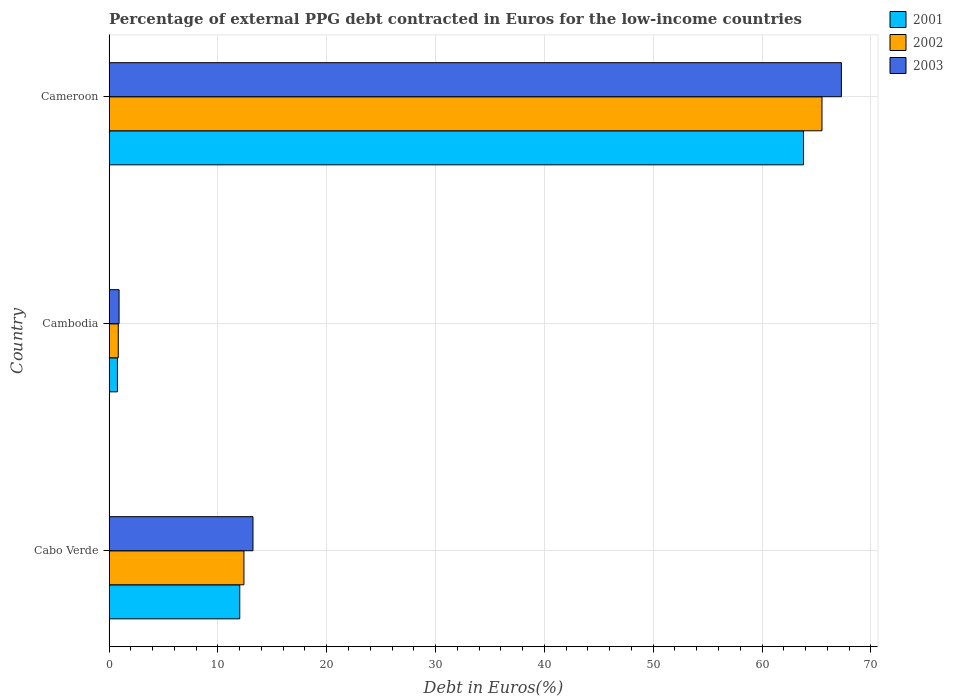How many different coloured bars are there?
Your answer should be very brief. 3. How many groups of bars are there?
Give a very brief answer. 3. Are the number of bars per tick equal to the number of legend labels?
Your response must be concise. Yes. What is the label of the 2nd group of bars from the top?
Your response must be concise. Cambodia. What is the percentage of external PPG debt contracted in Euros in 2002 in Cameroon?
Your response must be concise. 65.51. Across all countries, what is the maximum percentage of external PPG debt contracted in Euros in 2003?
Offer a terse response. 67.29. Across all countries, what is the minimum percentage of external PPG debt contracted in Euros in 2001?
Offer a terse response. 0.77. In which country was the percentage of external PPG debt contracted in Euros in 2001 maximum?
Keep it short and to the point. Cameroon. In which country was the percentage of external PPG debt contracted in Euros in 2003 minimum?
Make the answer very short. Cambodia. What is the total percentage of external PPG debt contracted in Euros in 2001 in the graph?
Provide a succinct answer. 76.59. What is the difference between the percentage of external PPG debt contracted in Euros in 2003 in Cabo Verde and that in Cambodia?
Give a very brief answer. 12.31. What is the difference between the percentage of external PPG debt contracted in Euros in 2002 in Cameroon and the percentage of external PPG debt contracted in Euros in 2003 in Cambodia?
Your response must be concise. 64.59. What is the average percentage of external PPG debt contracted in Euros in 2001 per country?
Your response must be concise. 25.53. What is the difference between the percentage of external PPG debt contracted in Euros in 2002 and percentage of external PPG debt contracted in Euros in 2003 in Cambodia?
Offer a terse response. -0.07. In how many countries, is the percentage of external PPG debt contracted in Euros in 2002 greater than 14 %?
Give a very brief answer. 1. What is the ratio of the percentage of external PPG debt contracted in Euros in 2002 in Cabo Verde to that in Cameroon?
Give a very brief answer. 0.19. Is the percentage of external PPG debt contracted in Euros in 2002 in Cabo Verde less than that in Cameroon?
Offer a terse response. Yes. What is the difference between the highest and the second highest percentage of external PPG debt contracted in Euros in 2002?
Provide a succinct answer. 53.12. What is the difference between the highest and the lowest percentage of external PPG debt contracted in Euros in 2003?
Provide a succinct answer. 66.37. Is the sum of the percentage of external PPG debt contracted in Euros in 2001 in Cambodia and Cameroon greater than the maximum percentage of external PPG debt contracted in Euros in 2003 across all countries?
Your answer should be compact. No. How many bars are there?
Make the answer very short. 9. How many countries are there in the graph?
Give a very brief answer. 3. How are the legend labels stacked?
Your answer should be compact. Vertical. What is the title of the graph?
Give a very brief answer. Percentage of external PPG debt contracted in Euros for the low-income countries. Does "1999" appear as one of the legend labels in the graph?
Give a very brief answer. No. What is the label or title of the X-axis?
Offer a very short reply. Debt in Euros(%). What is the Debt in Euros(%) in 2001 in Cabo Verde?
Your response must be concise. 12.01. What is the Debt in Euros(%) of 2002 in Cabo Verde?
Your answer should be compact. 12.39. What is the Debt in Euros(%) of 2003 in Cabo Verde?
Provide a succinct answer. 13.22. What is the Debt in Euros(%) of 2001 in Cambodia?
Make the answer very short. 0.77. What is the Debt in Euros(%) in 2002 in Cambodia?
Offer a very short reply. 0.85. What is the Debt in Euros(%) in 2003 in Cambodia?
Give a very brief answer. 0.92. What is the Debt in Euros(%) in 2001 in Cameroon?
Keep it short and to the point. 63.81. What is the Debt in Euros(%) in 2002 in Cameroon?
Your response must be concise. 65.51. What is the Debt in Euros(%) in 2003 in Cameroon?
Offer a very short reply. 67.29. Across all countries, what is the maximum Debt in Euros(%) in 2001?
Offer a very short reply. 63.81. Across all countries, what is the maximum Debt in Euros(%) in 2002?
Provide a short and direct response. 65.51. Across all countries, what is the maximum Debt in Euros(%) in 2003?
Your answer should be compact. 67.29. Across all countries, what is the minimum Debt in Euros(%) in 2001?
Your answer should be compact. 0.77. Across all countries, what is the minimum Debt in Euros(%) of 2002?
Ensure brevity in your answer.  0.85. Across all countries, what is the minimum Debt in Euros(%) of 2003?
Give a very brief answer. 0.92. What is the total Debt in Euros(%) in 2001 in the graph?
Offer a terse response. 76.59. What is the total Debt in Euros(%) of 2002 in the graph?
Your answer should be compact. 78.75. What is the total Debt in Euros(%) in 2003 in the graph?
Provide a succinct answer. 81.43. What is the difference between the Debt in Euros(%) in 2001 in Cabo Verde and that in Cambodia?
Make the answer very short. 11.24. What is the difference between the Debt in Euros(%) of 2002 in Cabo Verde and that in Cambodia?
Provide a short and direct response. 11.55. What is the difference between the Debt in Euros(%) in 2003 in Cabo Verde and that in Cambodia?
Offer a terse response. 12.31. What is the difference between the Debt in Euros(%) of 2001 in Cabo Verde and that in Cameroon?
Provide a short and direct response. -51.8. What is the difference between the Debt in Euros(%) of 2002 in Cabo Verde and that in Cameroon?
Offer a very short reply. -53.12. What is the difference between the Debt in Euros(%) in 2003 in Cabo Verde and that in Cameroon?
Ensure brevity in your answer.  -54.07. What is the difference between the Debt in Euros(%) of 2001 in Cambodia and that in Cameroon?
Keep it short and to the point. -63.04. What is the difference between the Debt in Euros(%) of 2002 in Cambodia and that in Cameroon?
Your answer should be very brief. -64.66. What is the difference between the Debt in Euros(%) in 2003 in Cambodia and that in Cameroon?
Keep it short and to the point. -66.37. What is the difference between the Debt in Euros(%) in 2001 in Cabo Verde and the Debt in Euros(%) in 2002 in Cambodia?
Provide a succinct answer. 11.16. What is the difference between the Debt in Euros(%) of 2001 in Cabo Verde and the Debt in Euros(%) of 2003 in Cambodia?
Provide a succinct answer. 11.09. What is the difference between the Debt in Euros(%) of 2002 in Cabo Verde and the Debt in Euros(%) of 2003 in Cambodia?
Give a very brief answer. 11.47. What is the difference between the Debt in Euros(%) of 2001 in Cabo Verde and the Debt in Euros(%) of 2002 in Cameroon?
Give a very brief answer. -53.5. What is the difference between the Debt in Euros(%) of 2001 in Cabo Verde and the Debt in Euros(%) of 2003 in Cameroon?
Your answer should be compact. -55.28. What is the difference between the Debt in Euros(%) of 2002 in Cabo Verde and the Debt in Euros(%) of 2003 in Cameroon?
Offer a terse response. -54.9. What is the difference between the Debt in Euros(%) of 2001 in Cambodia and the Debt in Euros(%) of 2002 in Cameroon?
Offer a very short reply. -64.74. What is the difference between the Debt in Euros(%) in 2001 in Cambodia and the Debt in Euros(%) in 2003 in Cameroon?
Provide a succinct answer. -66.52. What is the difference between the Debt in Euros(%) in 2002 in Cambodia and the Debt in Euros(%) in 2003 in Cameroon?
Make the answer very short. -66.44. What is the average Debt in Euros(%) in 2001 per country?
Ensure brevity in your answer.  25.53. What is the average Debt in Euros(%) of 2002 per country?
Give a very brief answer. 26.25. What is the average Debt in Euros(%) in 2003 per country?
Your answer should be very brief. 27.14. What is the difference between the Debt in Euros(%) of 2001 and Debt in Euros(%) of 2002 in Cabo Verde?
Give a very brief answer. -0.38. What is the difference between the Debt in Euros(%) in 2001 and Debt in Euros(%) in 2003 in Cabo Verde?
Provide a short and direct response. -1.21. What is the difference between the Debt in Euros(%) of 2002 and Debt in Euros(%) of 2003 in Cabo Verde?
Your answer should be very brief. -0.83. What is the difference between the Debt in Euros(%) of 2001 and Debt in Euros(%) of 2002 in Cambodia?
Provide a short and direct response. -0.08. What is the difference between the Debt in Euros(%) of 2001 and Debt in Euros(%) of 2003 in Cambodia?
Offer a terse response. -0.15. What is the difference between the Debt in Euros(%) of 2002 and Debt in Euros(%) of 2003 in Cambodia?
Your response must be concise. -0.07. What is the difference between the Debt in Euros(%) in 2001 and Debt in Euros(%) in 2002 in Cameroon?
Provide a succinct answer. -1.7. What is the difference between the Debt in Euros(%) of 2001 and Debt in Euros(%) of 2003 in Cameroon?
Provide a short and direct response. -3.48. What is the difference between the Debt in Euros(%) in 2002 and Debt in Euros(%) in 2003 in Cameroon?
Provide a short and direct response. -1.78. What is the ratio of the Debt in Euros(%) of 2001 in Cabo Verde to that in Cambodia?
Your response must be concise. 15.6. What is the ratio of the Debt in Euros(%) of 2002 in Cabo Verde to that in Cambodia?
Provide a short and direct response. 14.64. What is the ratio of the Debt in Euros(%) in 2003 in Cabo Verde to that in Cambodia?
Keep it short and to the point. 14.41. What is the ratio of the Debt in Euros(%) in 2001 in Cabo Verde to that in Cameroon?
Give a very brief answer. 0.19. What is the ratio of the Debt in Euros(%) of 2002 in Cabo Verde to that in Cameroon?
Give a very brief answer. 0.19. What is the ratio of the Debt in Euros(%) in 2003 in Cabo Verde to that in Cameroon?
Offer a terse response. 0.2. What is the ratio of the Debt in Euros(%) of 2001 in Cambodia to that in Cameroon?
Offer a very short reply. 0.01. What is the ratio of the Debt in Euros(%) of 2002 in Cambodia to that in Cameroon?
Offer a very short reply. 0.01. What is the ratio of the Debt in Euros(%) of 2003 in Cambodia to that in Cameroon?
Make the answer very short. 0.01. What is the difference between the highest and the second highest Debt in Euros(%) in 2001?
Your answer should be very brief. 51.8. What is the difference between the highest and the second highest Debt in Euros(%) of 2002?
Offer a very short reply. 53.12. What is the difference between the highest and the second highest Debt in Euros(%) of 2003?
Offer a terse response. 54.07. What is the difference between the highest and the lowest Debt in Euros(%) of 2001?
Make the answer very short. 63.04. What is the difference between the highest and the lowest Debt in Euros(%) in 2002?
Your response must be concise. 64.66. What is the difference between the highest and the lowest Debt in Euros(%) in 2003?
Ensure brevity in your answer.  66.37. 